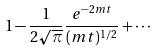<formula> <loc_0><loc_0><loc_500><loc_500>1 - \frac { 1 } { 2 \sqrt { \pi } } \frac { e ^ { - 2 m t } } { ( m t ) ^ { 1 / 2 } } + \cdots</formula> 